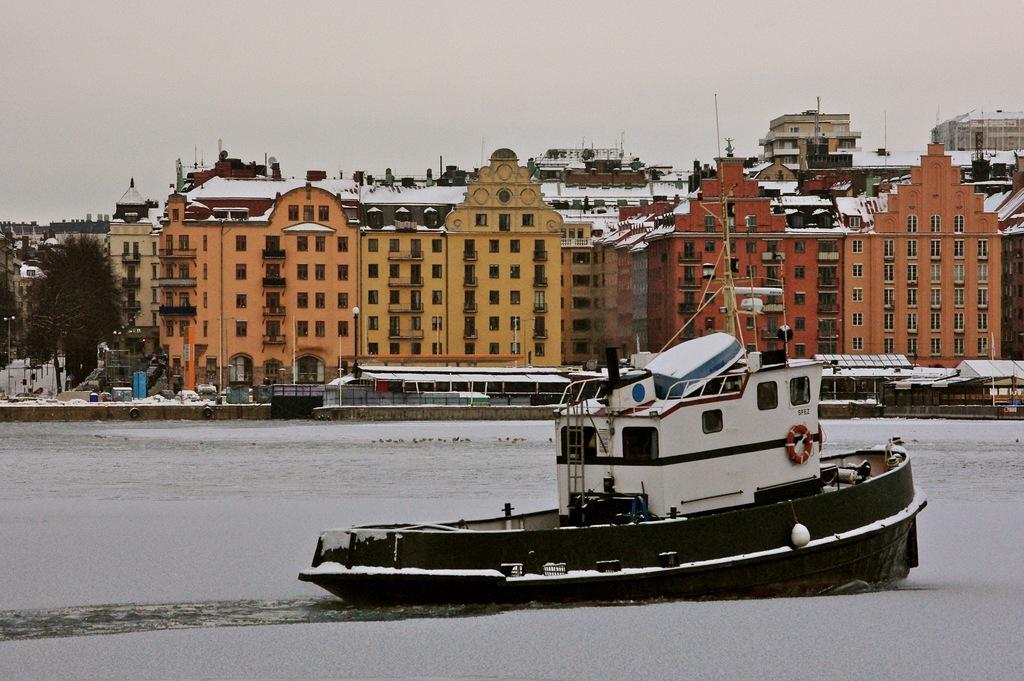What type of structures can be seen in the image? There are buildings in the image. What other natural elements are present in the image? There are trees in the image. What is in the water in the image? There is a boat in the water in the image. How would you describe the sky in the image? The sky is cloudy in the image. Where are the girls using the whip in the image? There are no girls or whips present in the image. Is there a volcano visible in the image? No, there is no volcano present in the image. 